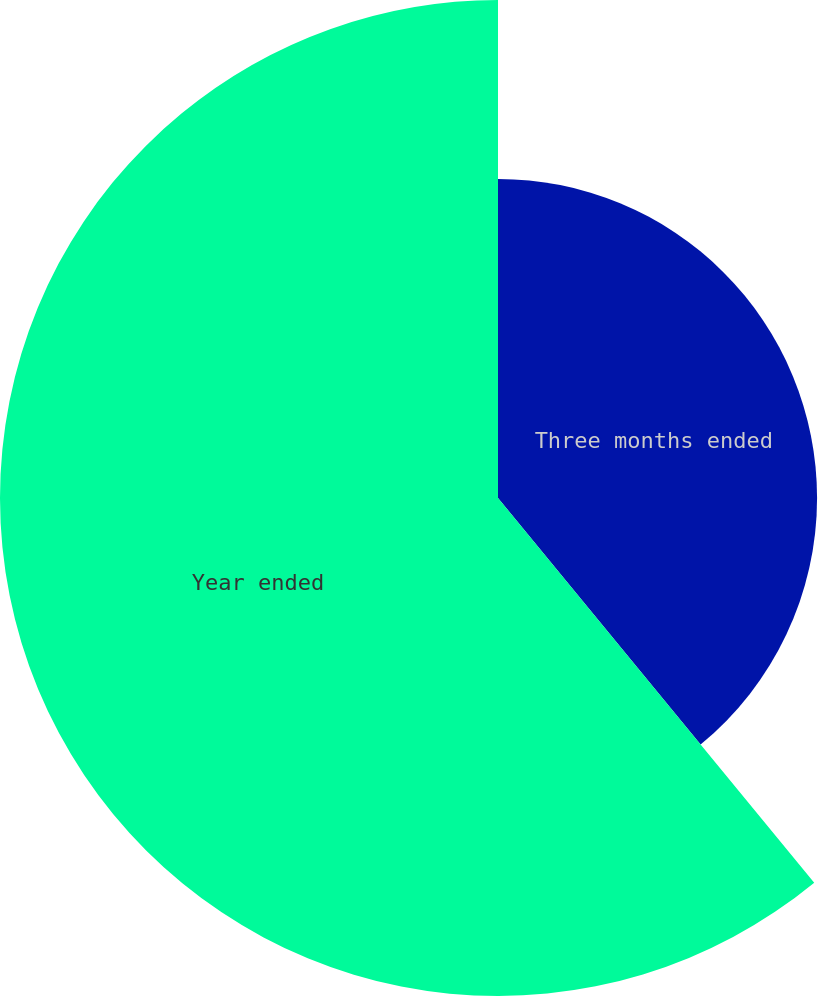<chart> <loc_0><loc_0><loc_500><loc_500><pie_chart><fcel>Three months ended<fcel>Year ended<nl><fcel>39.05%<fcel>60.95%<nl></chart> 